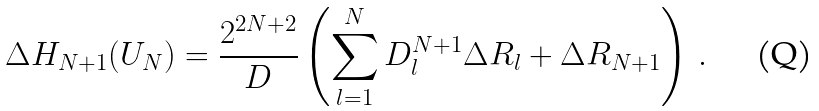<formula> <loc_0><loc_0><loc_500><loc_500>\Delta H _ { N + 1 } ( U _ { N } ) = \frac { 2 ^ { 2 N + 2 } } { D } \left ( \sum _ { l = 1 } ^ { N } D ^ { N + 1 } _ { l } \Delta R _ { l } + \Delta R _ { N + 1 } \right ) \, .</formula> 